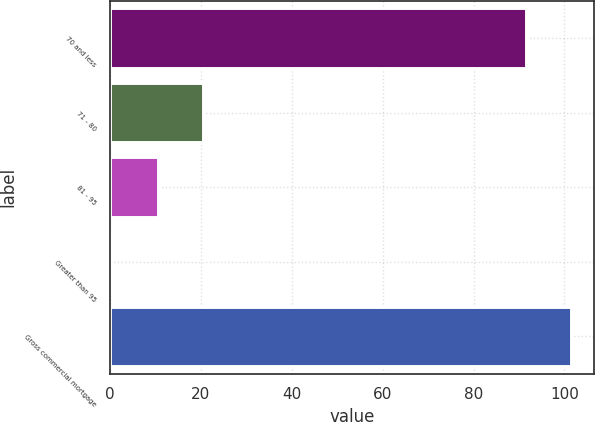<chart> <loc_0><loc_0><loc_500><loc_500><bar_chart><fcel>70 and less<fcel>71 - 80<fcel>81 - 95<fcel>Greater than 95<fcel>Gross commercial mortgage<nl><fcel>91.6<fcel>20.4<fcel>10.45<fcel>0.5<fcel>101.55<nl></chart> 